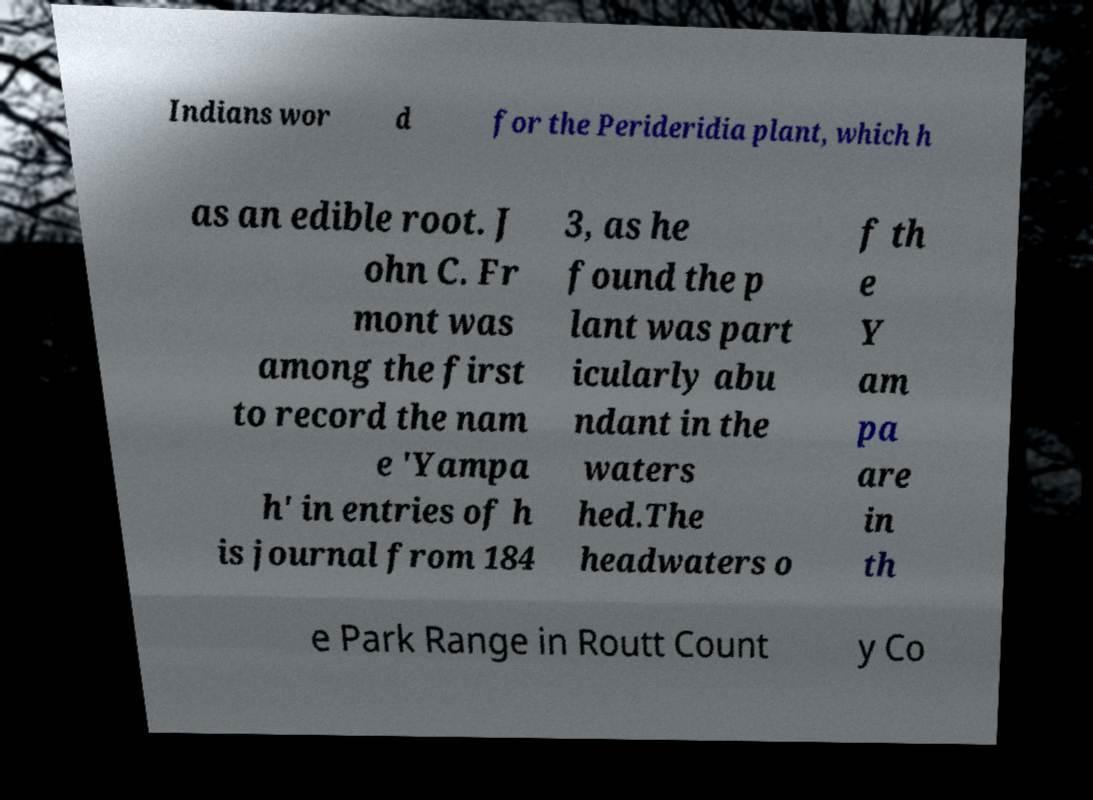Can you read and provide the text displayed in the image?This photo seems to have some interesting text. Can you extract and type it out for me? Indians wor d for the Perideridia plant, which h as an edible root. J ohn C. Fr mont was among the first to record the nam e 'Yampa h' in entries of h is journal from 184 3, as he found the p lant was part icularly abu ndant in the waters hed.The headwaters o f th e Y am pa are in th e Park Range in Routt Count y Co 